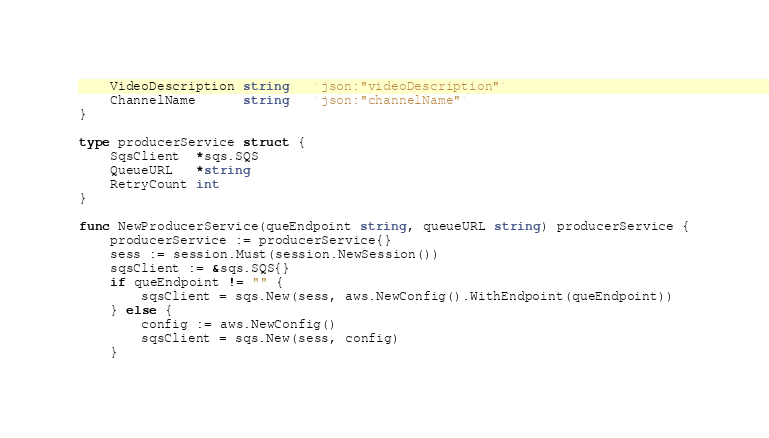Convert code to text. <code><loc_0><loc_0><loc_500><loc_500><_Go_>	VideoDescription string   `json:"videoDescription"`
	ChannelName      string   `json:"channelName"`
}

type producerService struct {
	SqsClient  *sqs.SQS
	QueueURL   *string
	RetryCount int
}

func NewProducerService(queEndpoint string, queueURL string) producerService {
	producerService := producerService{}
	sess := session.Must(session.NewSession())
	sqsClient := &sqs.SQS{}
	if queEndpoint != "" {
		sqsClient = sqs.New(sess, aws.NewConfig().WithEndpoint(queEndpoint))
	} else {
		config := aws.NewConfig()
		sqsClient = sqs.New(sess, config)
	}
</code> 